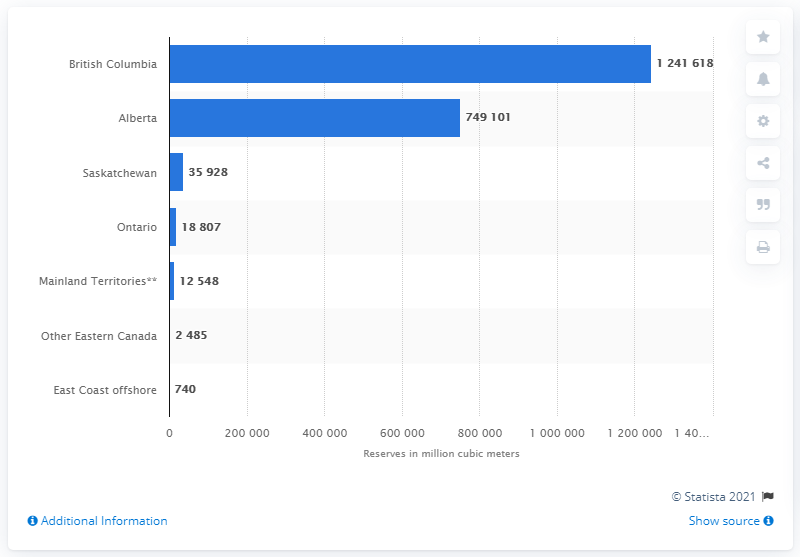List a handful of essential elements in this visual. In 2019, the total amount of natural gas in British Columbia was 124,161,800 cubic meters. Alberta ranked second in 2019 with a total natural gas production of 749.1 billion cubic meters. 